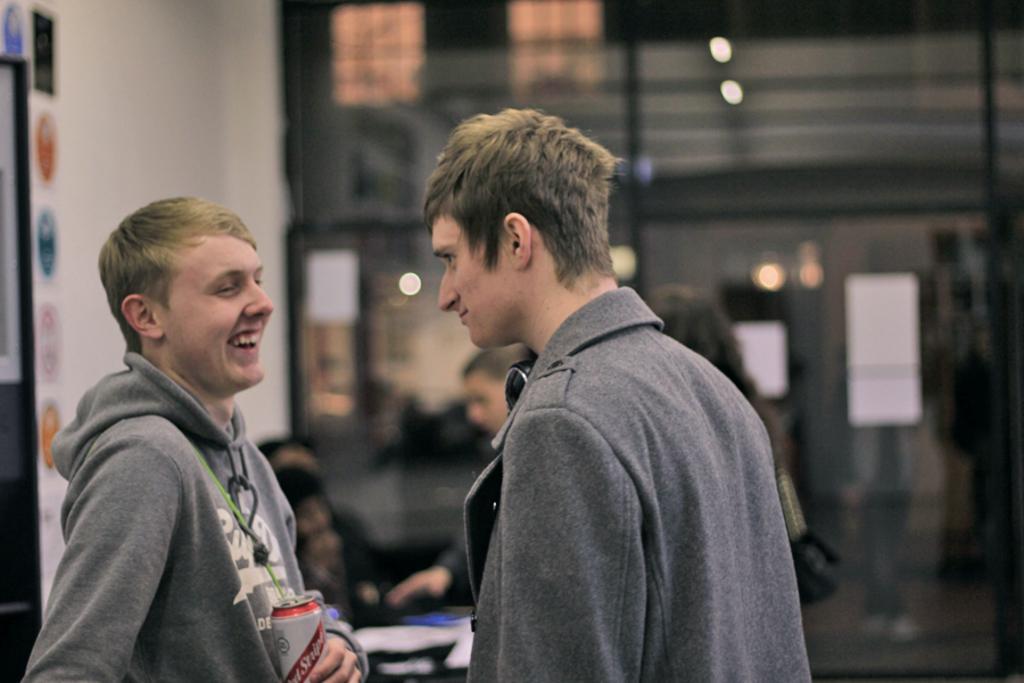Please provide a concise description of this image. In this image we can see a few persons, among them some are sitting and some are standing, in the background, we can see some windows, lights, and boards, on the left side of the image we can see a white color projector. 